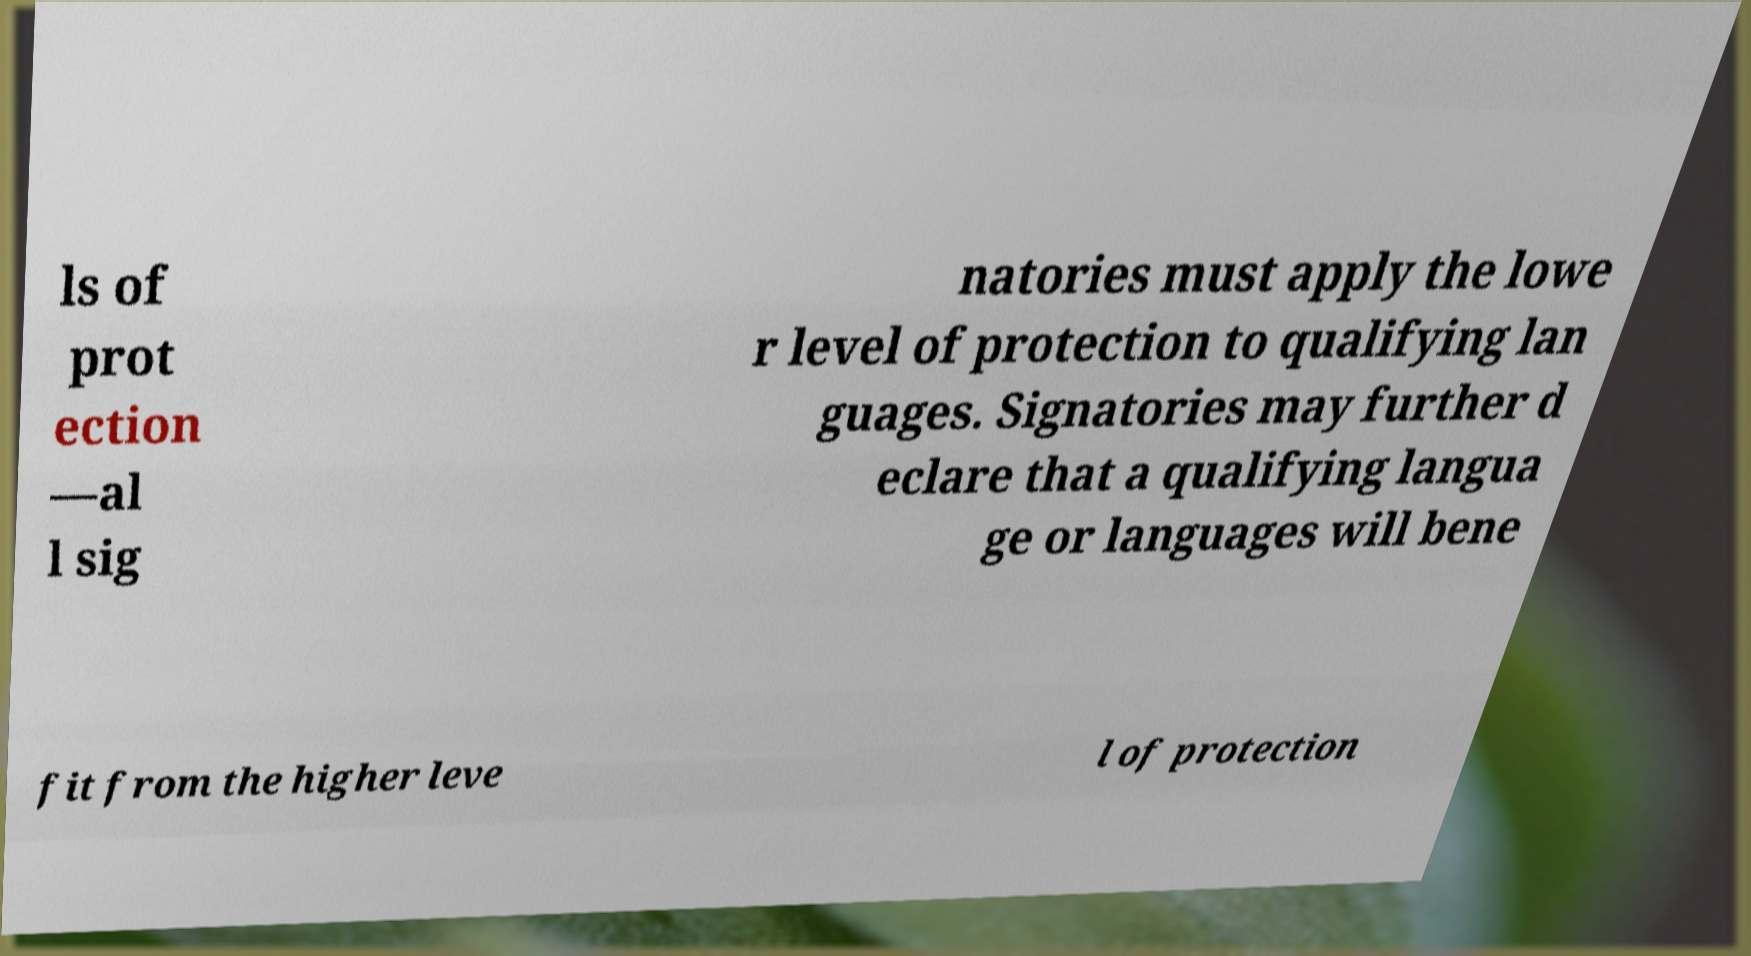There's text embedded in this image that I need extracted. Can you transcribe it verbatim? ls of prot ection —al l sig natories must apply the lowe r level of protection to qualifying lan guages. Signatories may further d eclare that a qualifying langua ge or languages will bene fit from the higher leve l of protection 